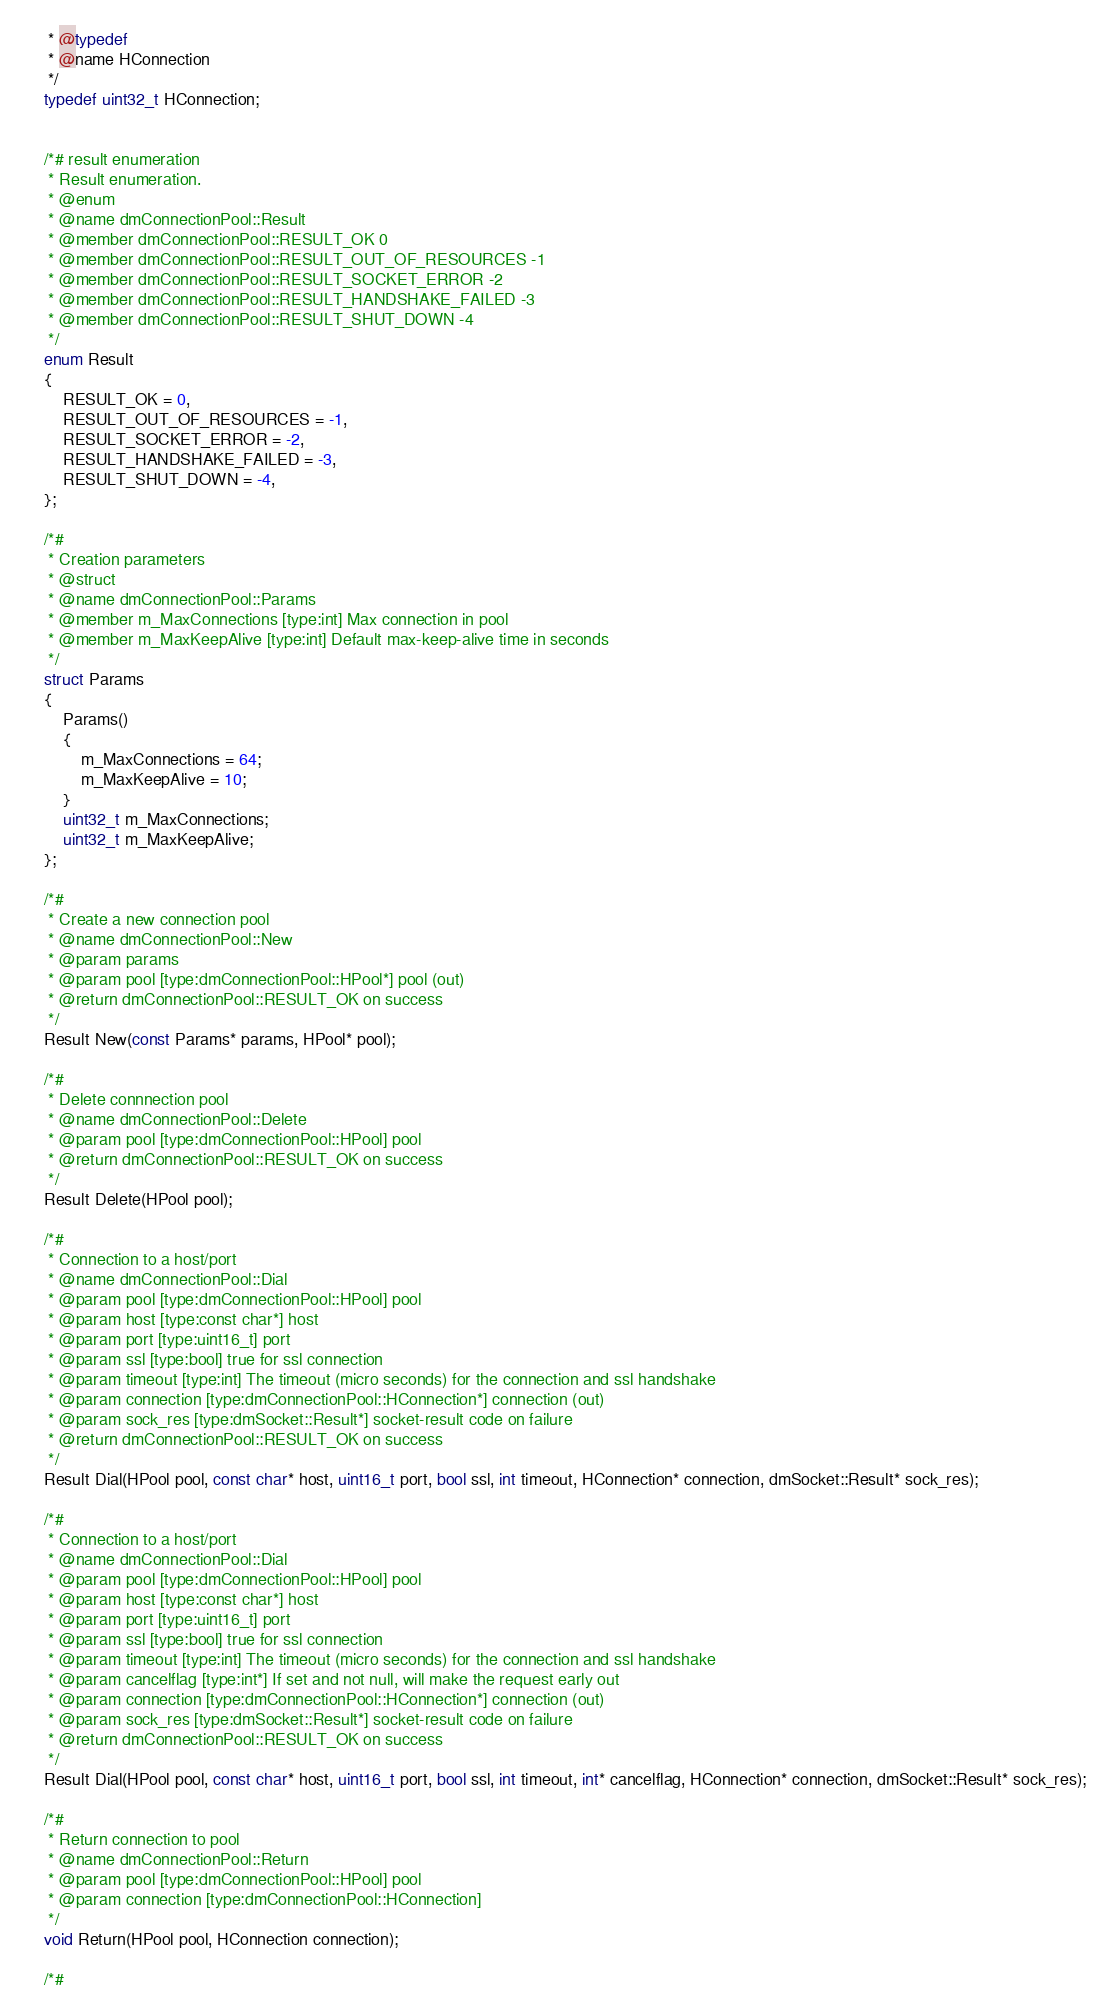<code> <loc_0><loc_0><loc_500><loc_500><_C_>     * @typedef
     * @name HConnection
     */
    typedef uint32_t HConnection;


    /*# result enumeration
     * Result enumeration.
     * @enum
     * @name dmConnectionPool::Result
     * @member dmConnectionPool::RESULT_OK 0
     * @member dmConnectionPool::RESULT_OUT_OF_RESOURCES -1
     * @member dmConnectionPool::RESULT_SOCKET_ERROR -2
     * @member dmConnectionPool::RESULT_HANDSHAKE_FAILED -3
     * @member dmConnectionPool::RESULT_SHUT_DOWN -4
     */
    enum Result
    {
        RESULT_OK = 0,
        RESULT_OUT_OF_RESOURCES = -1,
        RESULT_SOCKET_ERROR = -2,
        RESULT_HANDSHAKE_FAILED = -3,
        RESULT_SHUT_DOWN = -4,
    };

    /*#
     * Creation parameters
     * @struct
     * @name dmConnectionPool::Params
     * @member m_MaxConnections [type:int] Max connection in pool
     * @member m_MaxKeepAlive [type:int] Default max-keep-alive time in seconds
     */
    struct Params
    {
        Params()
        {
            m_MaxConnections = 64;
            m_MaxKeepAlive = 10;
        }
        uint32_t m_MaxConnections;
        uint32_t m_MaxKeepAlive;
    };

    /*#
     * Create a new connection pool
     * @name dmConnectionPool::New
     * @param params
     * @param pool [type:dmConnectionPool::HPool*] pool (out)
     * @return dmConnectionPool::RESULT_OK on success
     */
    Result New(const Params* params, HPool* pool);

    /*#
     * Delete connnection pool
     * @name dmConnectionPool::Delete
     * @param pool [type:dmConnectionPool::HPool] pool
     * @return dmConnectionPool::RESULT_OK on success
     */
    Result Delete(HPool pool);

    /*#
     * Connection to a host/port
     * @name dmConnectionPool::Dial
     * @param pool [type:dmConnectionPool::HPool] pool
     * @param host [type:const char*] host
     * @param port [type:uint16_t] port
     * @param ssl [type:bool] true for ssl connection
     * @param timeout [type:int] The timeout (micro seconds) for the connection and ssl handshake
     * @param connection [type:dmConnectionPool::HConnection*] connection (out)
     * @param sock_res [type:dmSocket::Result*] socket-result code on failure
     * @return dmConnectionPool::RESULT_OK on success
     */
    Result Dial(HPool pool, const char* host, uint16_t port, bool ssl, int timeout, HConnection* connection, dmSocket::Result* sock_res);

    /*#
     * Connection to a host/port
     * @name dmConnectionPool::Dial
     * @param pool [type:dmConnectionPool::HPool] pool
     * @param host [type:const char*] host
     * @param port [type:uint16_t] port
     * @param ssl [type:bool] true for ssl connection
     * @param timeout [type:int] The timeout (micro seconds) for the connection and ssl handshake
     * @param cancelflag [type:int*] If set and not null, will make the request early out
     * @param connection [type:dmConnectionPool::HConnection*] connection (out)
     * @param sock_res [type:dmSocket::Result*] socket-result code on failure
     * @return dmConnectionPool::RESULT_OK on success
     */
    Result Dial(HPool pool, const char* host, uint16_t port, bool ssl, int timeout, int* cancelflag, HConnection* connection, dmSocket::Result* sock_res);

    /*#
     * Return connection to pool
     * @name dmConnectionPool::Return
     * @param pool [type:dmConnectionPool::HPool] pool
     * @param connection [type:dmConnectionPool::HConnection]
     */
    void Return(HPool pool, HConnection connection);

    /*#</code> 